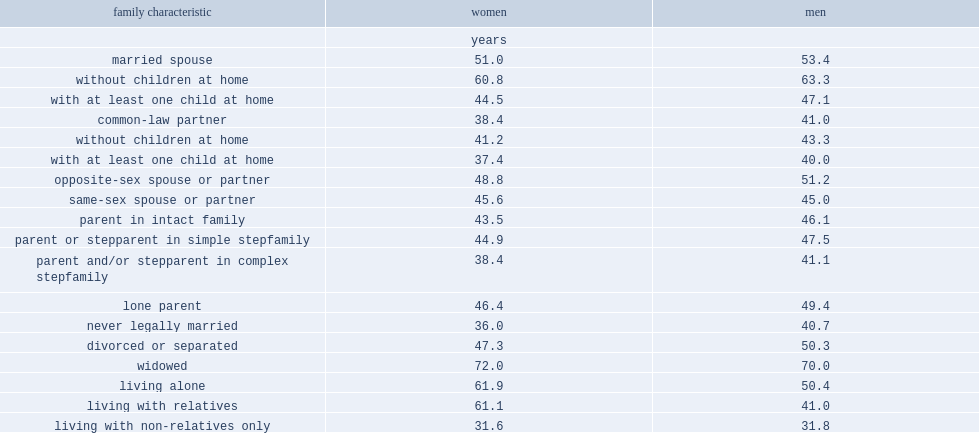Help me parse the entirety of this table. {'header': ['family characteristic', 'women', 'men'], 'rows': [['', 'years', ''], ['married spouse', '51.0', '53.4'], ['without children at home', '60.8', '63.3'], ['with at least one child at home', '44.5', '47.1'], ['common-law partner', '38.4', '41.0'], ['without children at home', '41.2', '43.3'], ['with at least one child at home', '37.4', '40.0'], ['opposite-sex spouse or partner', '48.8', '51.2'], ['same-sex spouse or partner', '45.6', '45.0'], ['parent in intact family', '43.5', '46.1'], ['parent or stepparent in simple stepfamily', '44.9', '47.5'], ['parent and/or stepparent in complex stepfamily', '38.4', '41.1'], ['lone parent', '46.4', '49.4'], ['never legally married', '36.0', '40.7'], ['divorced or separated', '47.3', '50.3'], ['widowed', '72.0', '70.0'], ['living alone', '61.9', '50.4'], ['living with relatives', '61.1', '41.0'], ['living with non-relatives only', '31.6', '31.8']]} What is the median age of marrid women in 2011? 51.0. What was the median age for married men in 2011? 53.4. What was the median age for male common-law partners in 2011? 41.0. 